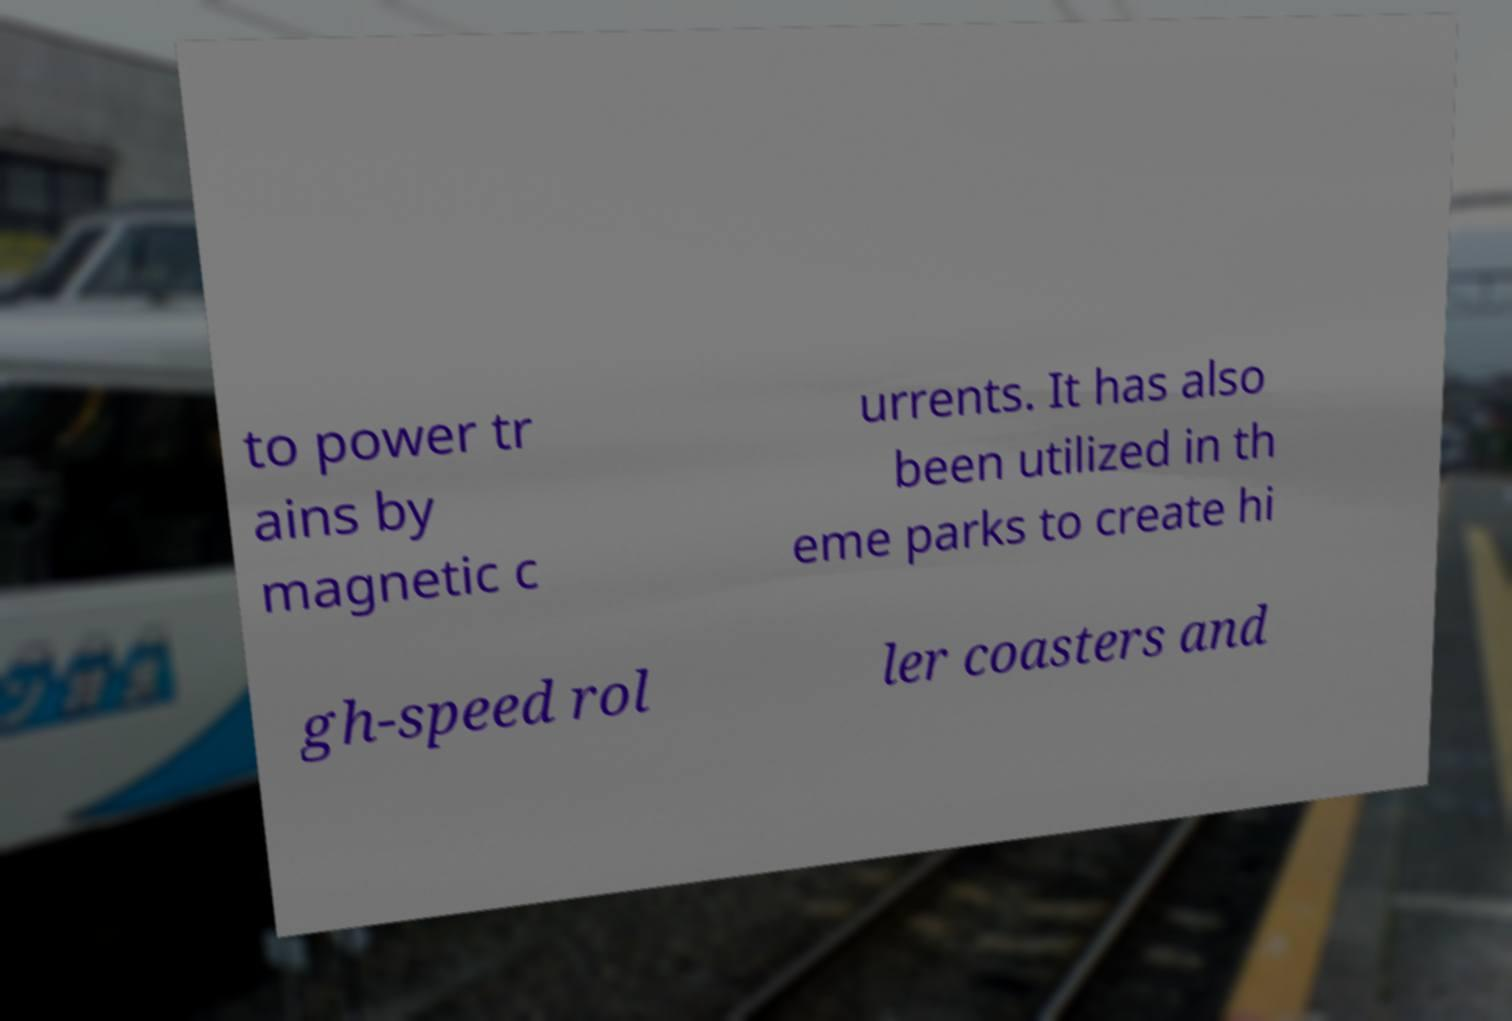Could you extract and type out the text from this image? to power tr ains by magnetic c urrents. It has also been utilized in th eme parks to create hi gh-speed rol ler coasters and 